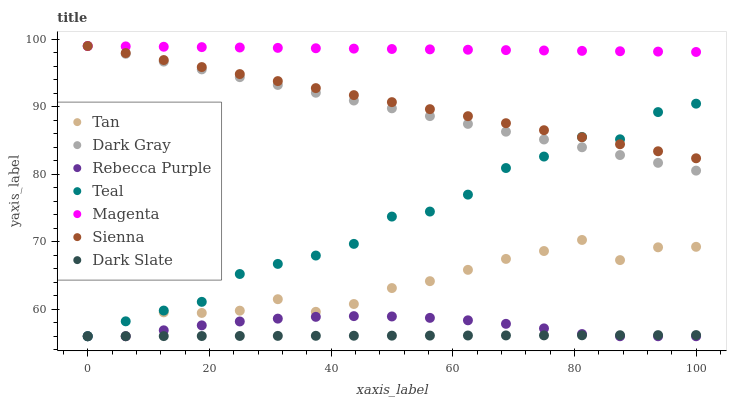Does Dark Slate have the minimum area under the curve?
Answer yes or no. Yes. Does Magenta have the maximum area under the curve?
Answer yes or no. Yes. Does Dark Gray have the minimum area under the curve?
Answer yes or no. No. Does Dark Gray have the maximum area under the curve?
Answer yes or no. No. Is Sienna the smoothest?
Answer yes or no. Yes. Is Tan the roughest?
Answer yes or no. Yes. Is Dark Gray the smoothest?
Answer yes or no. No. Is Dark Gray the roughest?
Answer yes or no. No. Does Dark Slate have the lowest value?
Answer yes or no. Yes. Does Dark Gray have the lowest value?
Answer yes or no. No. Does Magenta have the highest value?
Answer yes or no. Yes. Does Dark Slate have the highest value?
Answer yes or no. No. Is Dark Slate less than Dark Gray?
Answer yes or no. Yes. Is Magenta greater than Tan?
Answer yes or no. Yes. Does Magenta intersect Sienna?
Answer yes or no. Yes. Is Magenta less than Sienna?
Answer yes or no. No. Is Magenta greater than Sienna?
Answer yes or no. No. Does Dark Slate intersect Dark Gray?
Answer yes or no. No. 